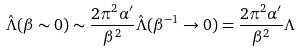Convert formula to latex. <formula><loc_0><loc_0><loc_500><loc_500>\hat { \Lambda } ( \beta \sim 0 ) \sim \frac { 2 \pi ^ { 2 } \alpha ^ { \prime } } { \beta ^ { 2 } } \hat { \Lambda } ( \beta ^ { - 1 } \rightarrow 0 ) = \frac { 2 \pi ^ { 2 } \alpha ^ { \prime } } { \beta ^ { 2 } } \Lambda</formula> 